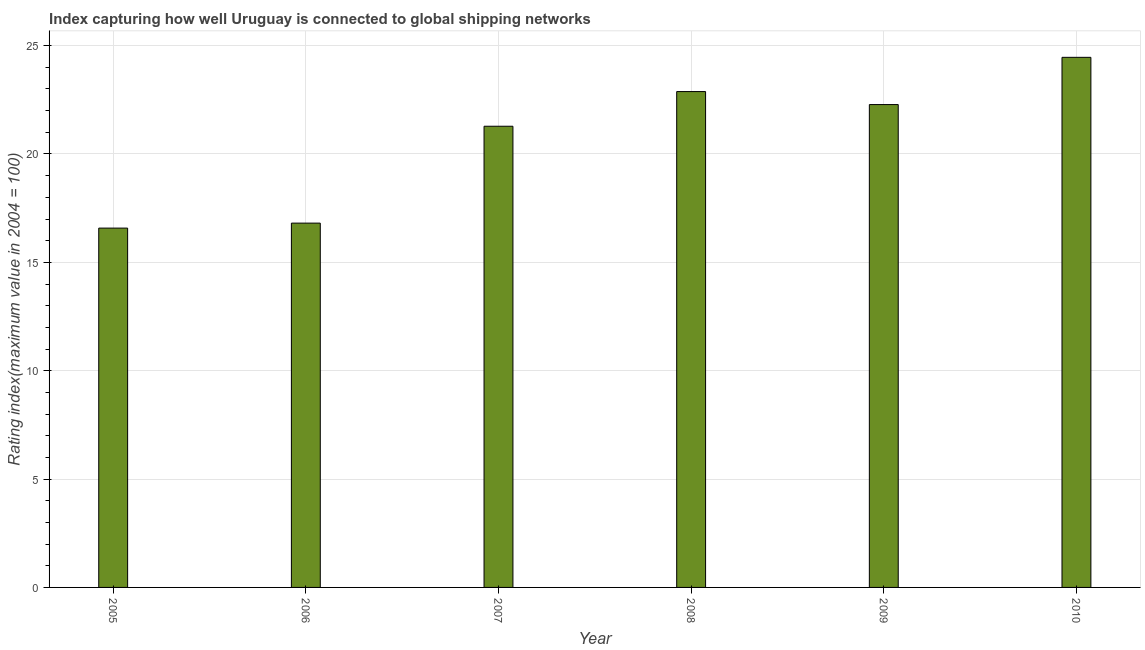Does the graph contain any zero values?
Give a very brief answer. No. Does the graph contain grids?
Give a very brief answer. Yes. What is the title of the graph?
Offer a very short reply. Index capturing how well Uruguay is connected to global shipping networks. What is the label or title of the Y-axis?
Ensure brevity in your answer.  Rating index(maximum value in 2004 = 100). What is the liner shipping connectivity index in 2005?
Your answer should be compact. 16.58. Across all years, what is the maximum liner shipping connectivity index?
Your answer should be compact. 24.46. Across all years, what is the minimum liner shipping connectivity index?
Provide a short and direct response. 16.58. In which year was the liner shipping connectivity index maximum?
Your answer should be very brief. 2010. What is the sum of the liner shipping connectivity index?
Offer a very short reply. 124.29. What is the difference between the liner shipping connectivity index in 2006 and 2010?
Offer a terse response. -7.65. What is the average liner shipping connectivity index per year?
Provide a succinct answer. 20.71. What is the median liner shipping connectivity index?
Make the answer very short. 21.78. In how many years, is the liner shipping connectivity index greater than 17 ?
Provide a short and direct response. 4. What is the ratio of the liner shipping connectivity index in 2009 to that in 2010?
Your answer should be compact. 0.91. Is the liner shipping connectivity index in 2007 less than that in 2008?
Offer a terse response. Yes. Is the difference between the liner shipping connectivity index in 2009 and 2010 greater than the difference between any two years?
Provide a succinct answer. No. What is the difference between the highest and the second highest liner shipping connectivity index?
Your answer should be compact. 1.58. What is the difference between the highest and the lowest liner shipping connectivity index?
Offer a terse response. 7.88. In how many years, is the liner shipping connectivity index greater than the average liner shipping connectivity index taken over all years?
Keep it short and to the point. 4. How many bars are there?
Keep it short and to the point. 6. What is the difference between two consecutive major ticks on the Y-axis?
Your answer should be compact. 5. What is the Rating index(maximum value in 2004 = 100) in 2005?
Offer a very short reply. 16.58. What is the Rating index(maximum value in 2004 = 100) of 2006?
Keep it short and to the point. 16.81. What is the Rating index(maximum value in 2004 = 100) of 2007?
Provide a short and direct response. 21.28. What is the Rating index(maximum value in 2004 = 100) of 2008?
Keep it short and to the point. 22.88. What is the Rating index(maximum value in 2004 = 100) in 2009?
Your answer should be very brief. 22.28. What is the Rating index(maximum value in 2004 = 100) of 2010?
Give a very brief answer. 24.46. What is the difference between the Rating index(maximum value in 2004 = 100) in 2005 and 2006?
Give a very brief answer. -0.23. What is the difference between the Rating index(maximum value in 2004 = 100) in 2005 and 2007?
Provide a short and direct response. -4.7. What is the difference between the Rating index(maximum value in 2004 = 100) in 2005 and 2009?
Keep it short and to the point. -5.7. What is the difference between the Rating index(maximum value in 2004 = 100) in 2005 and 2010?
Provide a succinct answer. -7.88. What is the difference between the Rating index(maximum value in 2004 = 100) in 2006 and 2007?
Make the answer very short. -4.47. What is the difference between the Rating index(maximum value in 2004 = 100) in 2006 and 2008?
Your answer should be very brief. -6.07. What is the difference between the Rating index(maximum value in 2004 = 100) in 2006 and 2009?
Your answer should be compact. -5.47. What is the difference between the Rating index(maximum value in 2004 = 100) in 2006 and 2010?
Your answer should be very brief. -7.65. What is the difference between the Rating index(maximum value in 2004 = 100) in 2007 and 2008?
Provide a succinct answer. -1.6. What is the difference between the Rating index(maximum value in 2004 = 100) in 2007 and 2009?
Provide a succinct answer. -1. What is the difference between the Rating index(maximum value in 2004 = 100) in 2007 and 2010?
Provide a short and direct response. -3.18. What is the difference between the Rating index(maximum value in 2004 = 100) in 2008 and 2010?
Ensure brevity in your answer.  -1.58. What is the difference between the Rating index(maximum value in 2004 = 100) in 2009 and 2010?
Offer a very short reply. -2.18. What is the ratio of the Rating index(maximum value in 2004 = 100) in 2005 to that in 2007?
Offer a very short reply. 0.78. What is the ratio of the Rating index(maximum value in 2004 = 100) in 2005 to that in 2008?
Offer a terse response. 0.72. What is the ratio of the Rating index(maximum value in 2004 = 100) in 2005 to that in 2009?
Your response must be concise. 0.74. What is the ratio of the Rating index(maximum value in 2004 = 100) in 2005 to that in 2010?
Give a very brief answer. 0.68. What is the ratio of the Rating index(maximum value in 2004 = 100) in 2006 to that in 2007?
Your answer should be compact. 0.79. What is the ratio of the Rating index(maximum value in 2004 = 100) in 2006 to that in 2008?
Your answer should be very brief. 0.73. What is the ratio of the Rating index(maximum value in 2004 = 100) in 2006 to that in 2009?
Your answer should be compact. 0.75. What is the ratio of the Rating index(maximum value in 2004 = 100) in 2006 to that in 2010?
Provide a succinct answer. 0.69. What is the ratio of the Rating index(maximum value in 2004 = 100) in 2007 to that in 2008?
Your answer should be very brief. 0.93. What is the ratio of the Rating index(maximum value in 2004 = 100) in 2007 to that in 2009?
Offer a terse response. 0.95. What is the ratio of the Rating index(maximum value in 2004 = 100) in 2007 to that in 2010?
Your answer should be very brief. 0.87. What is the ratio of the Rating index(maximum value in 2004 = 100) in 2008 to that in 2009?
Provide a succinct answer. 1.03. What is the ratio of the Rating index(maximum value in 2004 = 100) in 2008 to that in 2010?
Give a very brief answer. 0.94. What is the ratio of the Rating index(maximum value in 2004 = 100) in 2009 to that in 2010?
Your answer should be compact. 0.91. 